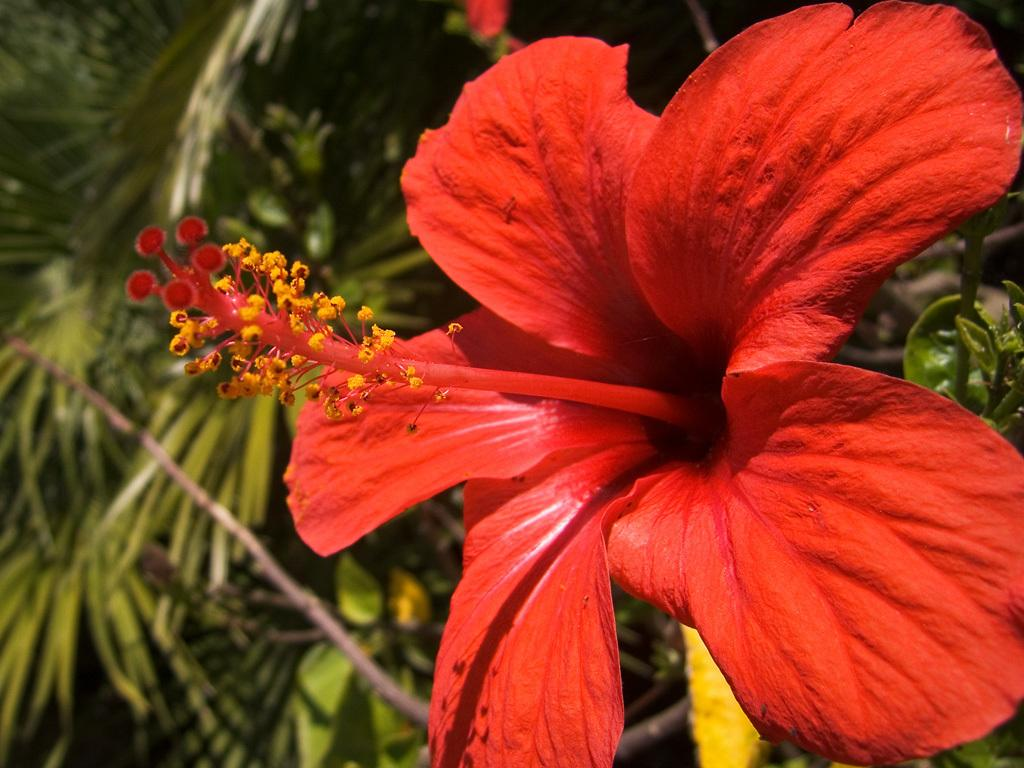What type of flower is in the image? There is a red color Hibiscus flower in the image. What other elements related to plants can be seen in the image? There are plants and petals visible in the image. What part of the flower is specifically mentioned in the facts? There is a petal visible in the image. What else is associated with the plants in the image? There are stems in the image. Who is the owner of the cork in the image? There is no cork present in the image. What type of dish is the cook preparing in the image? There is no cook or dish preparation present in the image. 